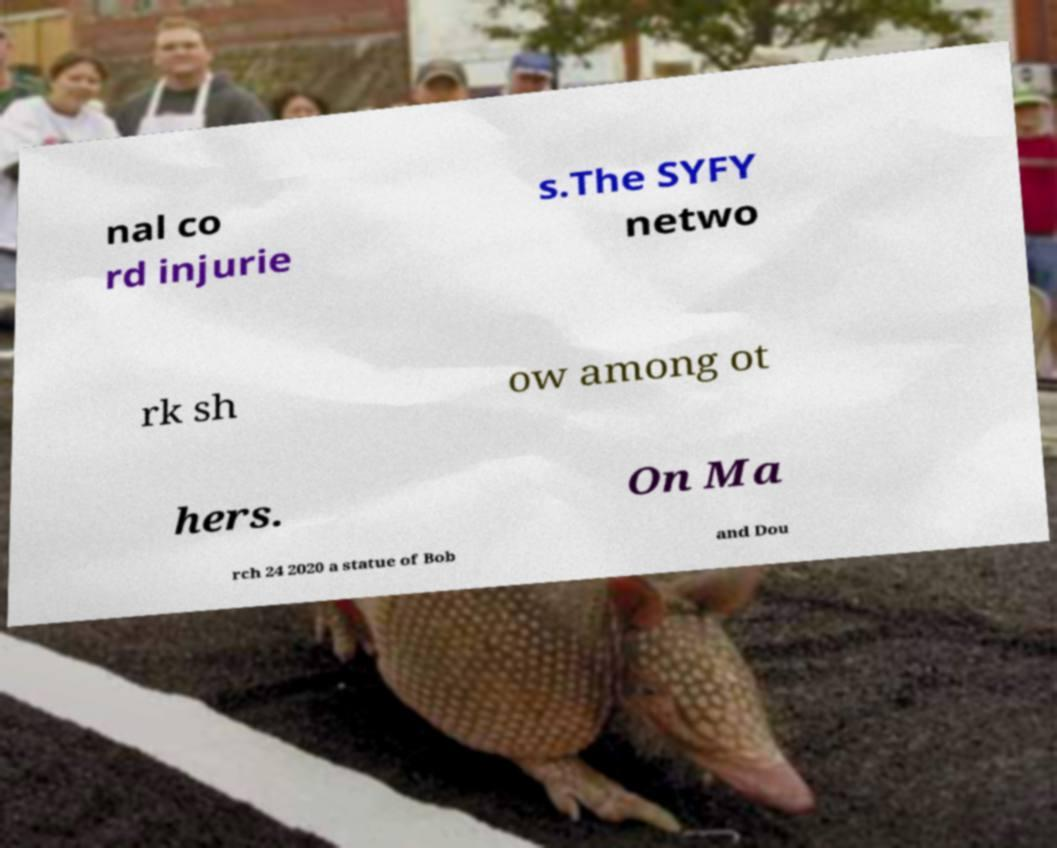I need the written content from this picture converted into text. Can you do that? nal co rd injurie s.The SYFY netwo rk sh ow among ot hers. On Ma rch 24 2020 a statue of Bob and Dou 